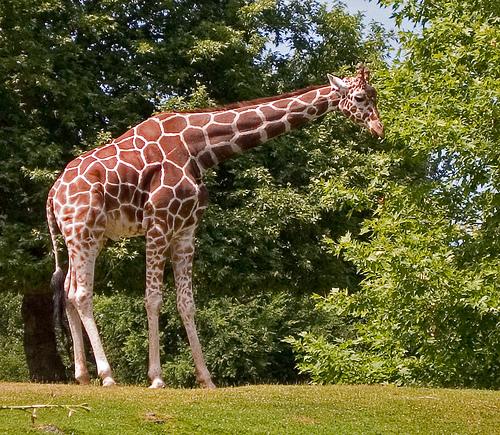Is the giraffe eating something?
Give a very brief answer. Yes. Is the giraffe a baby or an adult?
Write a very short answer. Adult. Is the giraffe standing tall?
Be succinct. No. How tall is the giraffe?
Give a very brief answer. Tall. Is the giraffe standing on grass?
Quick response, please. Yes. Is the giraffe eating?
Concise answer only. Yes. 